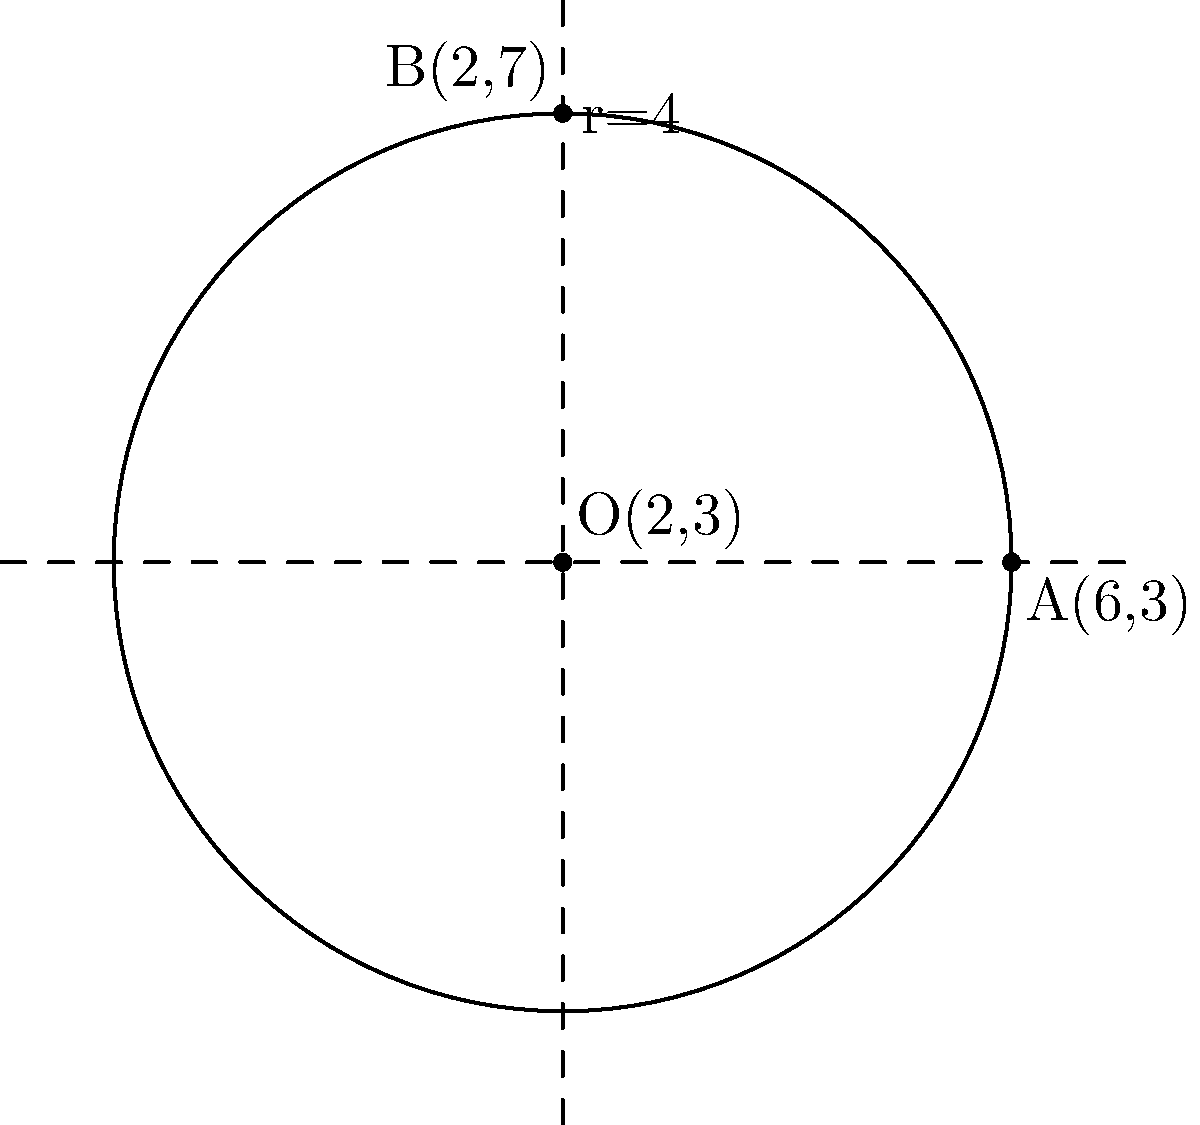During a boxing match interview, you need to explain the position of the ring to Polish journalists. The ring is represented by a circle in a coordinate system. Given that the equation of the circle is $$(x-2)^2 + (y-3)^2 = 16$$, determine the center and radius of the circle. How would you describe this in Polish boxing terminology? To find the center and radius of the circle, we need to analyze the given equation:

$$(x-2)^2 + (y-3)^2 = 16$$

1. The general equation of a circle is $(x-h)^2 + (y-k)^2 = r^2$, where $(h,k)$ is the center and $r$ is the radius.

2. Comparing our equation to the general form:
   - $(x-2)^2$ indicates that $h=2$
   - $(y-3)^2$ indicates that $k=3$
   - The right side, 16, is equal to $r^2$

3. Therefore, the center is $(2,3)$

4. To find the radius, we take the square root of 16:
   $r = \sqrt{16} = 4$

5. In Polish boxing terminology, we could describe this as:
   - Centrum ringu (center of the ring): (2,3)
   - Promień ringu (radius of the ring): 4 jednostki (4 units)

The circle represents the boxing ring, with its center at (2,3) and extending 4 units in all directions from this point.
Answer: Center: (2,3), Radius: 4 